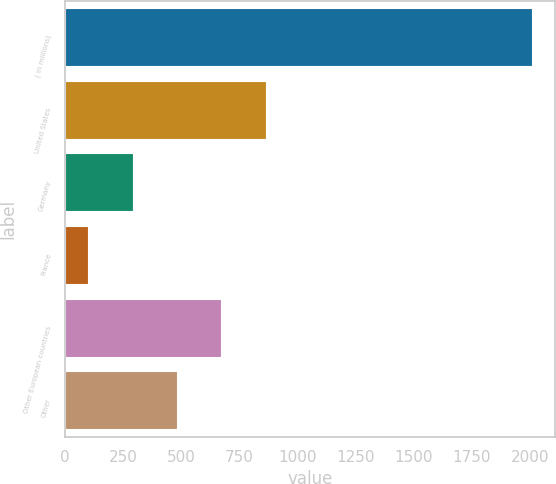Convert chart. <chart><loc_0><loc_0><loc_500><loc_500><bar_chart><fcel>( in millions)<fcel>United States<fcel>Germany<fcel>France<fcel>Other European countries<fcel>Other<nl><fcel>2007<fcel>862.68<fcel>290.52<fcel>99.8<fcel>671.96<fcel>481.24<nl></chart> 